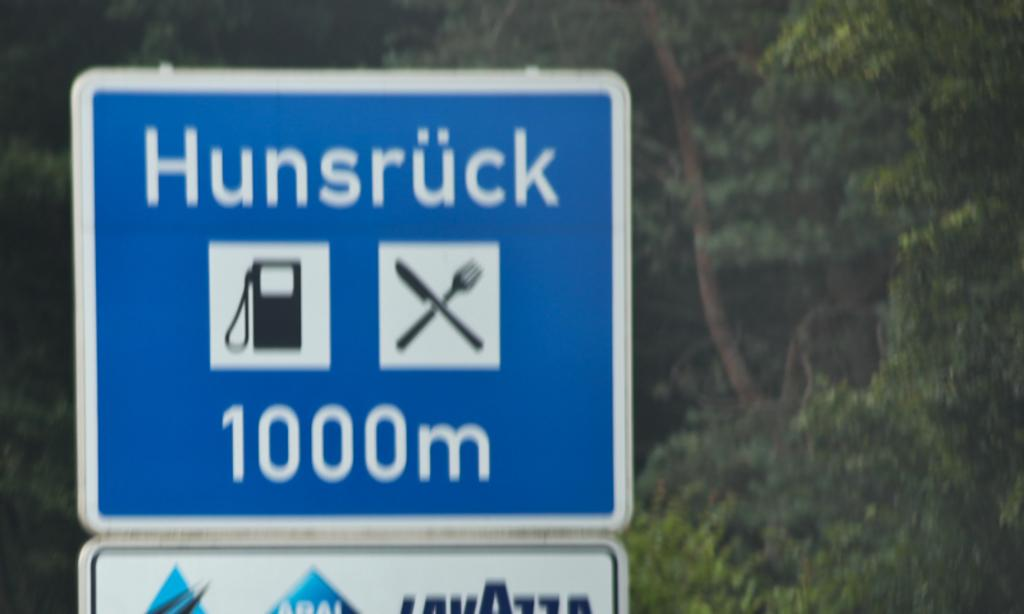<image>
Create a compact narrative representing the image presented. A blue, white and black sign reads hunsruck on top of it. 